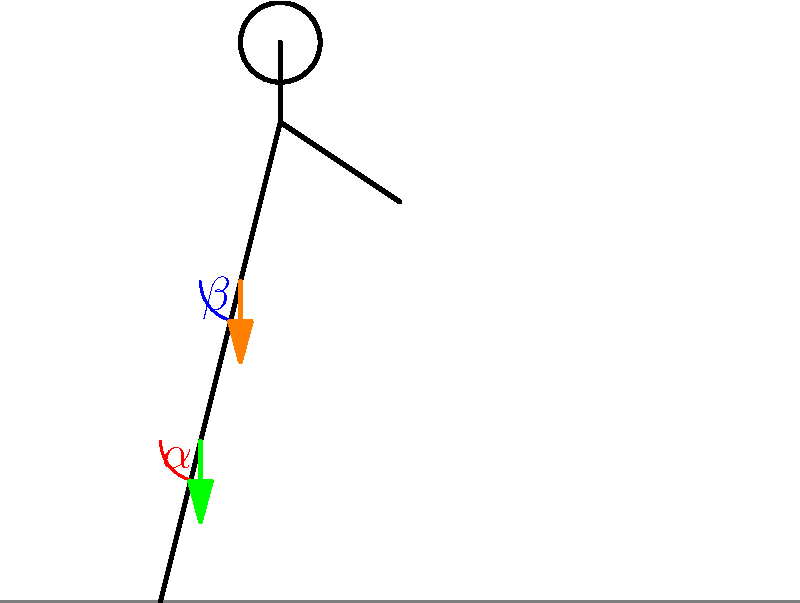In the stick figure diagram of a runner, angles $\alpha$ and $\beta$ represent the knee and hip angles, respectively. Which of the following statements is true regarding the relationship between these angles and the ground reaction force during the impact phase of running?

A) Increasing $\alpha$ and decreasing $\beta$ will reduce the ground reaction force
B) Decreasing $\alpha$ and increasing $\beta$ will reduce the ground reaction force
C) Increasing both $\alpha$ and $\beta$ will reduce the ground reaction force
D) Decreasing both $\alpha$ and $\beta$ will reduce the ground reaction force To understand the relationship between knee and hip angles and ground reaction force during running, let's follow these steps:

1. Impact phase: This is when the foot first contacts the ground during running.

2. Ground reaction force (GRF): This is the force exerted by the ground on the body in response to the body's force on the ground.

3. Knee angle ($\alpha$):
   - A smaller knee angle (more flexion) acts as a shock absorber.
   - It allows for greater energy absorption and reduces the impact force.

4. Hip angle ($\beta$):
   - A larger hip angle (more flexion) brings the center of mass closer to the ground.
   - This reduces the vertical displacement and, consequently, the impact force.

5. Combined effect:
   - Decreasing the knee angle ($\alpha$) increases leg compliance, allowing for better shock absorption.
   - Increasing the hip angle ($\beta$) lowers the center of mass, reducing the vertical impact.

6. Biomechanical principle:
   - Softer landings are achieved by increasing joint flexion, which increases the time over which the impact force is distributed.

7. Application to running form:
   - Proper running form involves a slightly increased hip flexion and decreased knee angle at impact.
   - This combination helps in reducing the overall ground reaction force and potential for injury.

Therefore, the correct answer is B: Decreasing $\alpha$ and increasing $\beta$ will reduce the ground reaction force during the impact phase of running.
Answer: Decreasing knee angle and increasing hip angle reduces ground reaction force. 